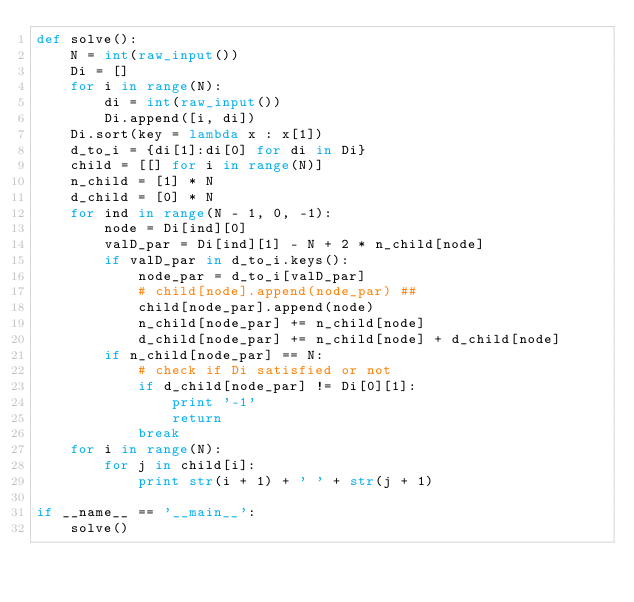<code> <loc_0><loc_0><loc_500><loc_500><_Python_>def solve():
    N = int(raw_input())
    Di = []
    for i in range(N):
        di = int(raw_input())
        Di.append([i, di])
    Di.sort(key = lambda x : x[1])
    d_to_i = {di[1]:di[0] for di in Di}
    child = [[] for i in range(N)]
    n_child = [1] * N
    d_child = [0] * N
    for ind in range(N - 1, 0, -1):
        node = Di[ind][0]
        valD_par = Di[ind][1] - N + 2 * n_child[node]
        if valD_par in d_to_i.keys():
            node_par = d_to_i[valD_par]
            # child[node].append(node_par) ##
            child[node_par].append(node)
            n_child[node_par] += n_child[node]
            d_child[node_par] += n_child[node] + d_child[node]
        if n_child[node_par] == N:
            # check if Di satisfied or not
            if d_child[node_par] != Di[0][1]:
                print '-1'
                return
            break
    for i in range(N):
        for j in child[i]:
            print str(i + 1) + ' ' + str(j + 1)

if __name__ == '__main__':
    solve()
</code> 